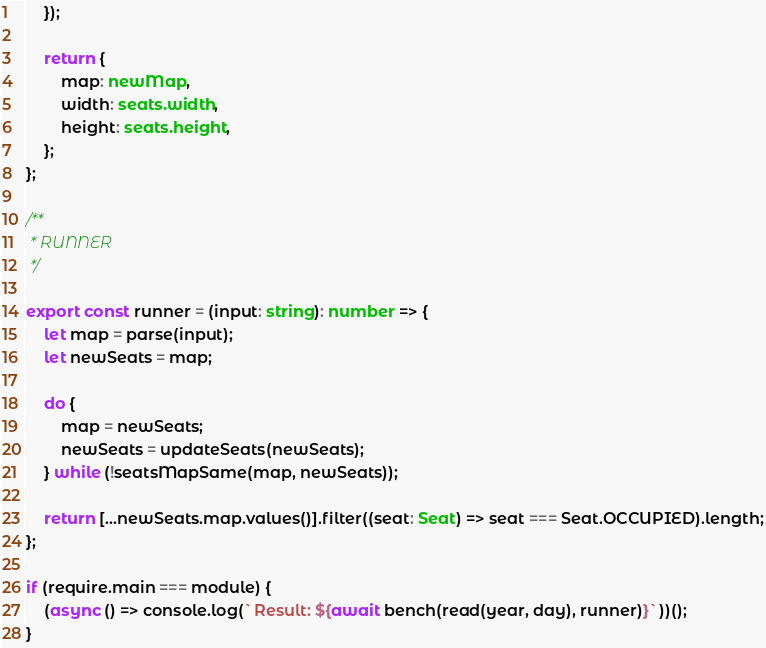Convert code to text. <code><loc_0><loc_0><loc_500><loc_500><_TypeScript_>	});

	return {
		map: newMap,
		width: seats.width,
		height: seats.height,
	};
};

/**
 * RUNNER
 */

export const runner = (input: string): number => {
	let map = parse(input);
	let newSeats = map;

	do {
		map = newSeats;
		newSeats = updateSeats(newSeats);
	} while (!seatsMapSame(map, newSeats));

	return [...newSeats.map.values()].filter((seat: Seat) => seat === Seat.OCCUPIED).length;
};

if (require.main === module) {
	(async () => console.log(`Result: ${await bench(read(year, day), runner)}`))();
}
</code> 